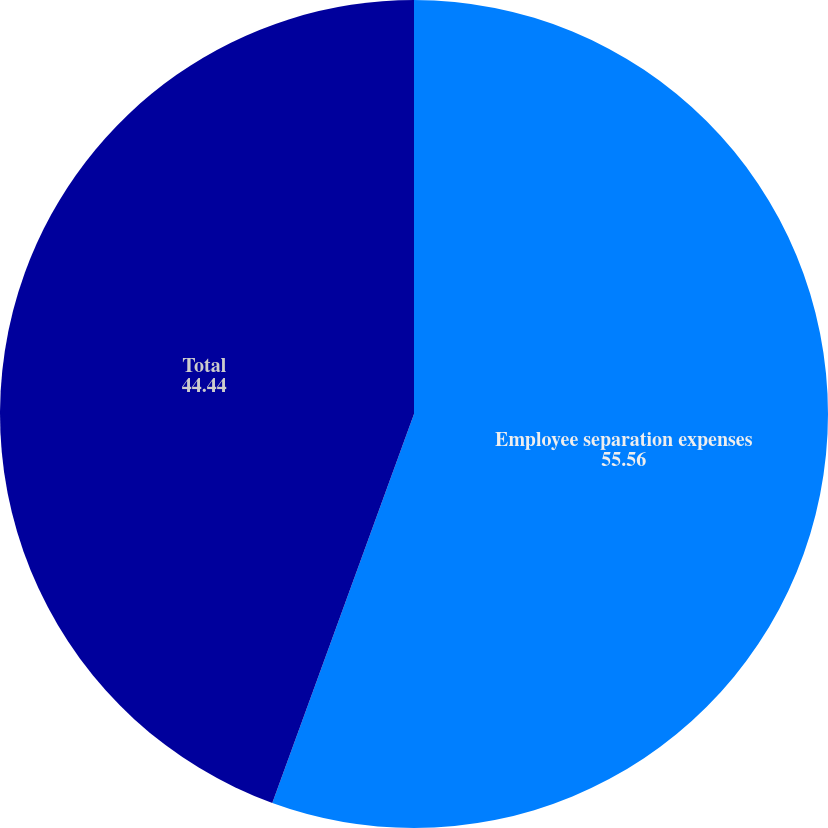<chart> <loc_0><loc_0><loc_500><loc_500><pie_chart><fcel>Employee separation expenses<fcel>Total<nl><fcel>55.56%<fcel>44.44%<nl></chart> 